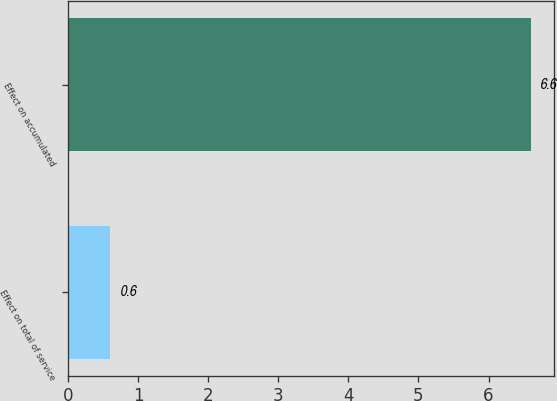<chart> <loc_0><loc_0><loc_500><loc_500><bar_chart><fcel>Effect on total of service<fcel>Effect on accumulated<nl><fcel>0.6<fcel>6.6<nl></chart> 